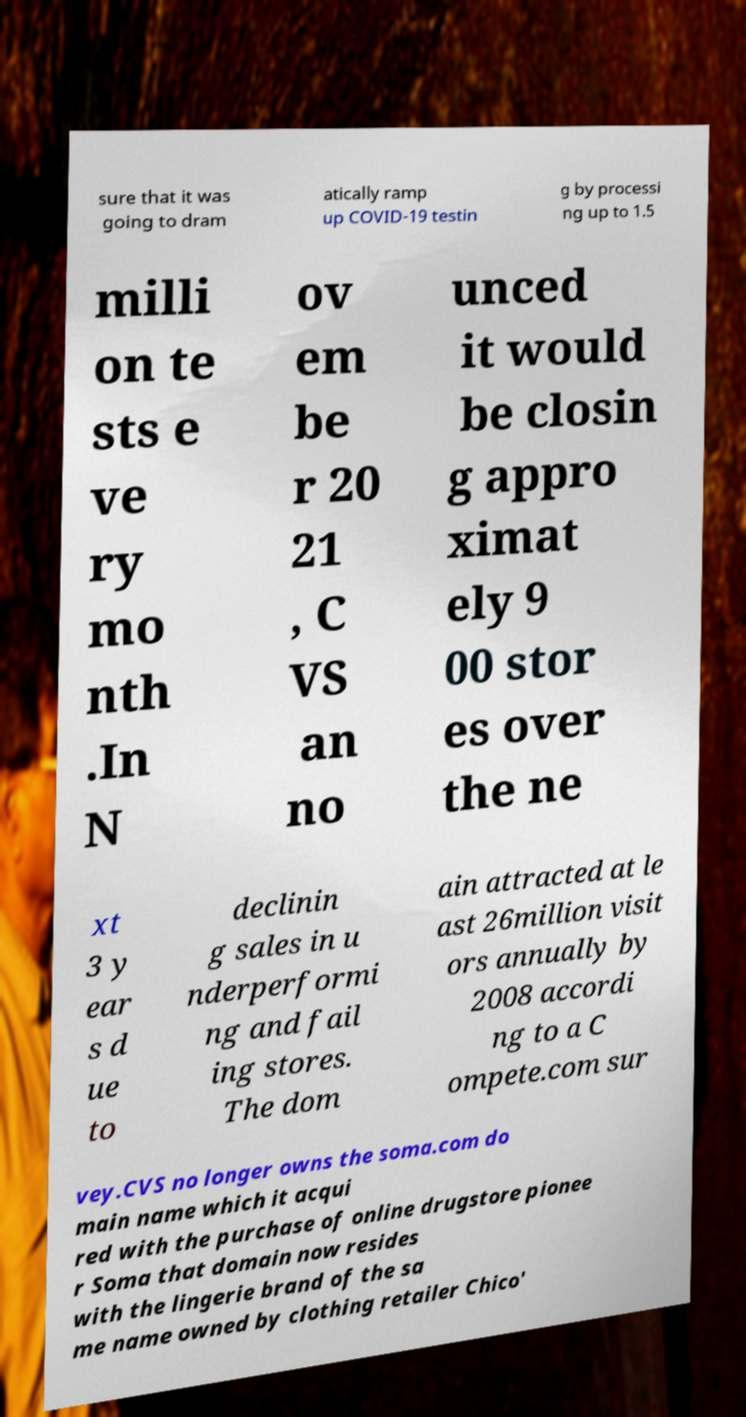There's text embedded in this image that I need extracted. Can you transcribe it verbatim? sure that it was going to dram atically ramp up COVID-19 testin g by processi ng up to 1.5 milli on te sts e ve ry mo nth .In N ov em be r 20 21 , C VS an no unced it would be closin g appro ximat ely 9 00 stor es over the ne xt 3 y ear s d ue to declinin g sales in u nderperformi ng and fail ing stores. The dom ain attracted at le ast 26million visit ors annually by 2008 accordi ng to a C ompete.com sur vey.CVS no longer owns the soma.com do main name which it acqui red with the purchase of online drugstore pionee r Soma that domain now resides with the lingerie brand of the sa me name owned by clothing retailer Chico' 